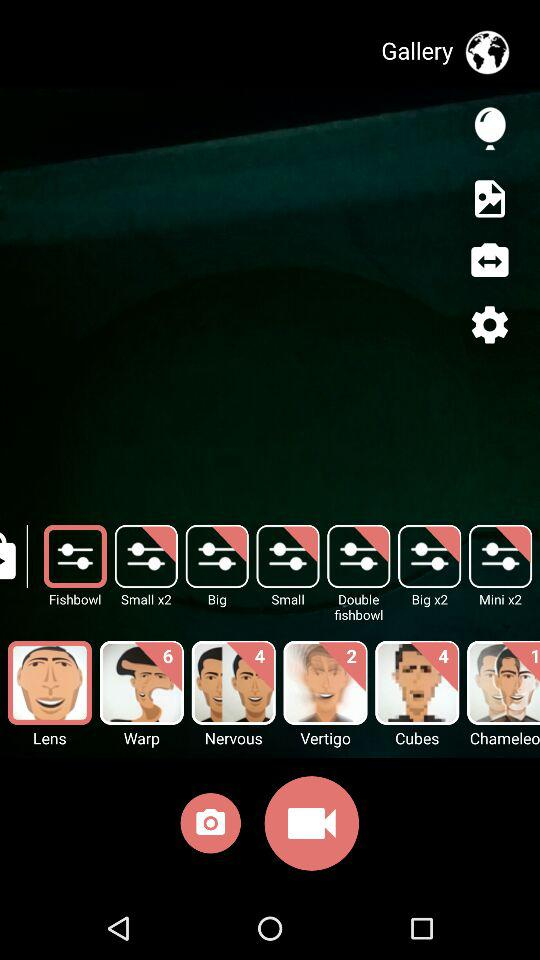Which filter is selected? The selected filter is "Lens". 